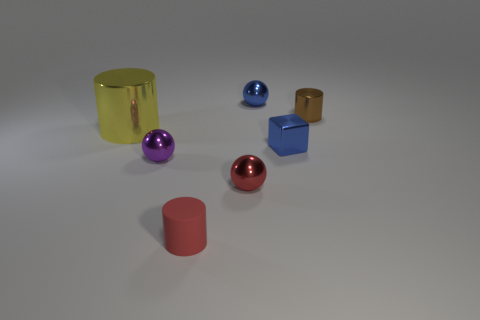How many purple metallic things are on the left side of the tiny object that is to the right of the tiny blue metallic thing that is on the right side of the blue shiny ball?
Offer a very short reply. 1. How big is the metallic cylinder left of the red thing right of the small red rubber object?
Make the answer very short. Large. There is a yellow thing that is made of the same material as the brown cylinder; what is its size?
Offer a very short reply. Large. What shape is the small metallic object that is both behind the tiny purple metal ball and in front of the brown cylinder?
Your answer should be very brief. Cube. Are there an equal number of spheres in front of the small brown cylinder and big shiny cylinders?
Offer a very short reply. No. How many objects are either blue shiny things or small spheres behind the big shiny thing?
Provide a short and direct response. 2. Is there a rubber object of the same shape as the small purple metal thing?
Keep it short and to the point. No. Are there the same number of tiny brown metallic cylinders that are on the left side of the blue ball and tiny blue shiny cubes that are behind the brown cylinder?
Keep it short and to the point. Yes. Is there anything else that is the same size as the yellow object?
Keep it short and to the point. No. What number of blue objects are big metal cylinders or blocks?
Offer a very short reply. 1. 